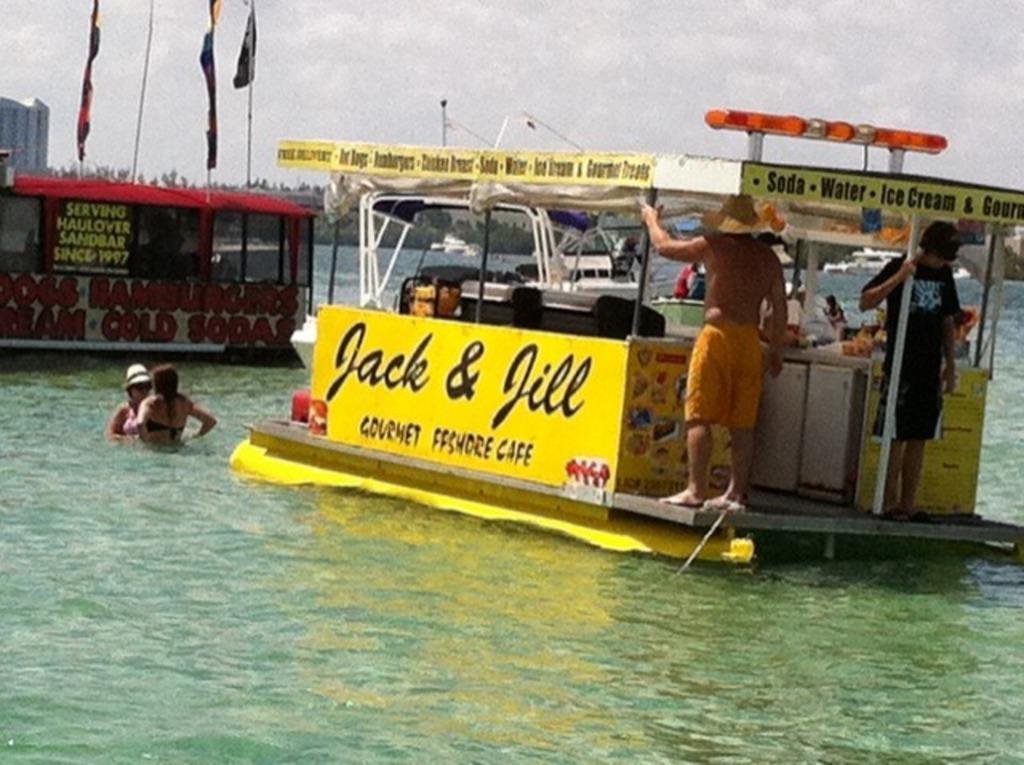Can you describe this image briefly? In this picture, we see the two men are standing on the yellow boat. Beside that, we see two women are swimming. Behind them, we see a red boat on which three flags are placed. There are many boats. There are many trees in the background. At the top of the picture, we see the sky and at the bottom of the picture, we see water and this water might be in the sea. 